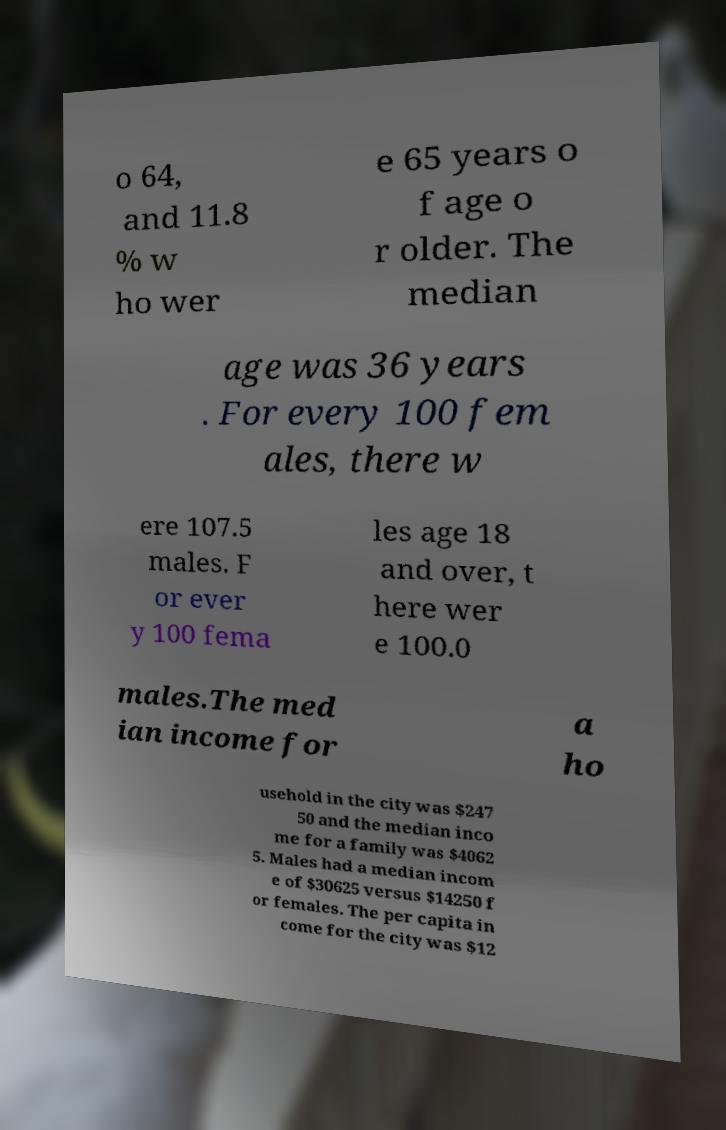Can you accurately transcribe the text from the provided image for me? o 64, and 11.8 % w ho wer e 65 years o f age o r older. The median age was 36 years . For every 100 fem ales, there w ere 107.5 males. F or ever y 100 fema les age 18 and over, t here wer e 100.0 males.The med ian income for a ho usehold in the city was $247 50 and the median inco me for a family was $4062 5. Males had a median incom e of $30625 versus $14250 f or females. The per capita in come for the city was $12 